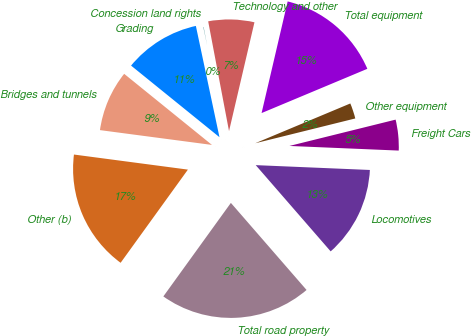Convert chart to OTSL. <chart><loc_0><loc_0><loc_500><loc_500><pie_chart><fcel>Concession land rights<fcel>Grading<fcel>Bridges and tunnels<fcel>Other (b)<fcel>Total road property<fcel>Locomotives<fcel>Freight Cars<fcel>Other equipment<fcel>Total equipment<fcel>Technology and other<nl><fcel>0.34%<fcel>10.84%<fcel>8.74%<fcel>17.14%<fcel>21.34%<fcel>12.94%<fcel>4.54%<fcel>2.44%<fcel>15.04%<fcel>6.64%<nl></chart> 